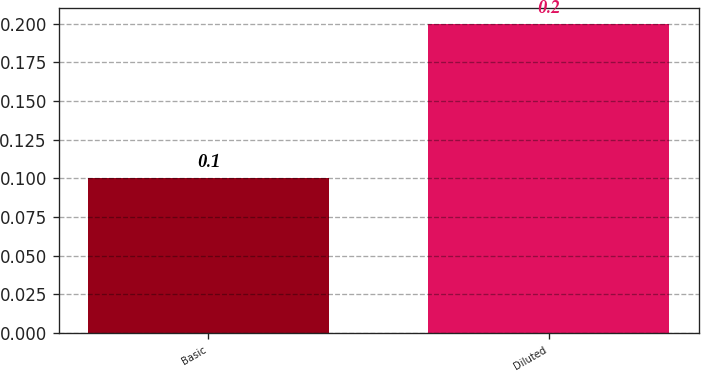Convert chart to OTSL. <chart><loc_0><loc_0><loc_500><loc_500><bar_chart><fcel>Basic<fcel>Diluted<nl><fcel>0.1<fcel>0.2<nl></chart> 